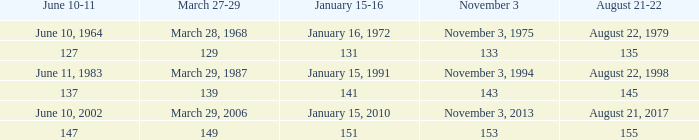On november 3, where is 149 for march 27-29? 153.0. 